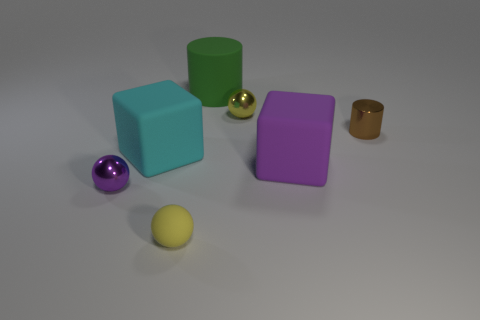The cyan matte thing that is the same size as the purple cube is what shape?
Make the answer very short. Cube. What number of other things are the same color as the matte sphere?
Provide a short and direct response. 1. Do the tiny purple thing that is to the left of the big green object and the small yellow object on the left side of the big green matte cylinder have the same shape?
Your answer should be very brief. Yes. How many objects are metallic objects right of the cyan thing or large rubber things left of the large green rubber cylinder?
Make the answer very short. 3. How many other objects are the same material as the cyan cube?
Provide a succinct answer. 3. Does the tiny yellow object in front of the purple block have the same material as the green thing?
Give a very brief answer. Yes. Are there more green rubber objects to the right of the big purple matte cube than yellow balls that are on the left side of the cyan thing?
Provide a succinct answer. No. How many objects are objects that are in front of the tiny purple metallic ball or green metal spheres?
Offer a terse response. 1. There is a yellow object that is made of the same material as the small cylinder; what shape is it?
Ensure brevity in your answer.  Sphere. Is there anything else that has the same shape as the green thing?
Provide a succinct answer. Yes. 